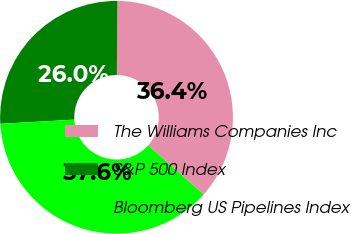Convert chart. <chart><loc_0><loc_0><loc_500><loc_500><pie_chart><fcel>The Williams Companies Inc<fcel>S&P 500 Index<fcel>Bloomberg US Pipelines Index<nl><fcel>36.42%<fcel>26.01%<fcel>37.57%<nl></chart> 